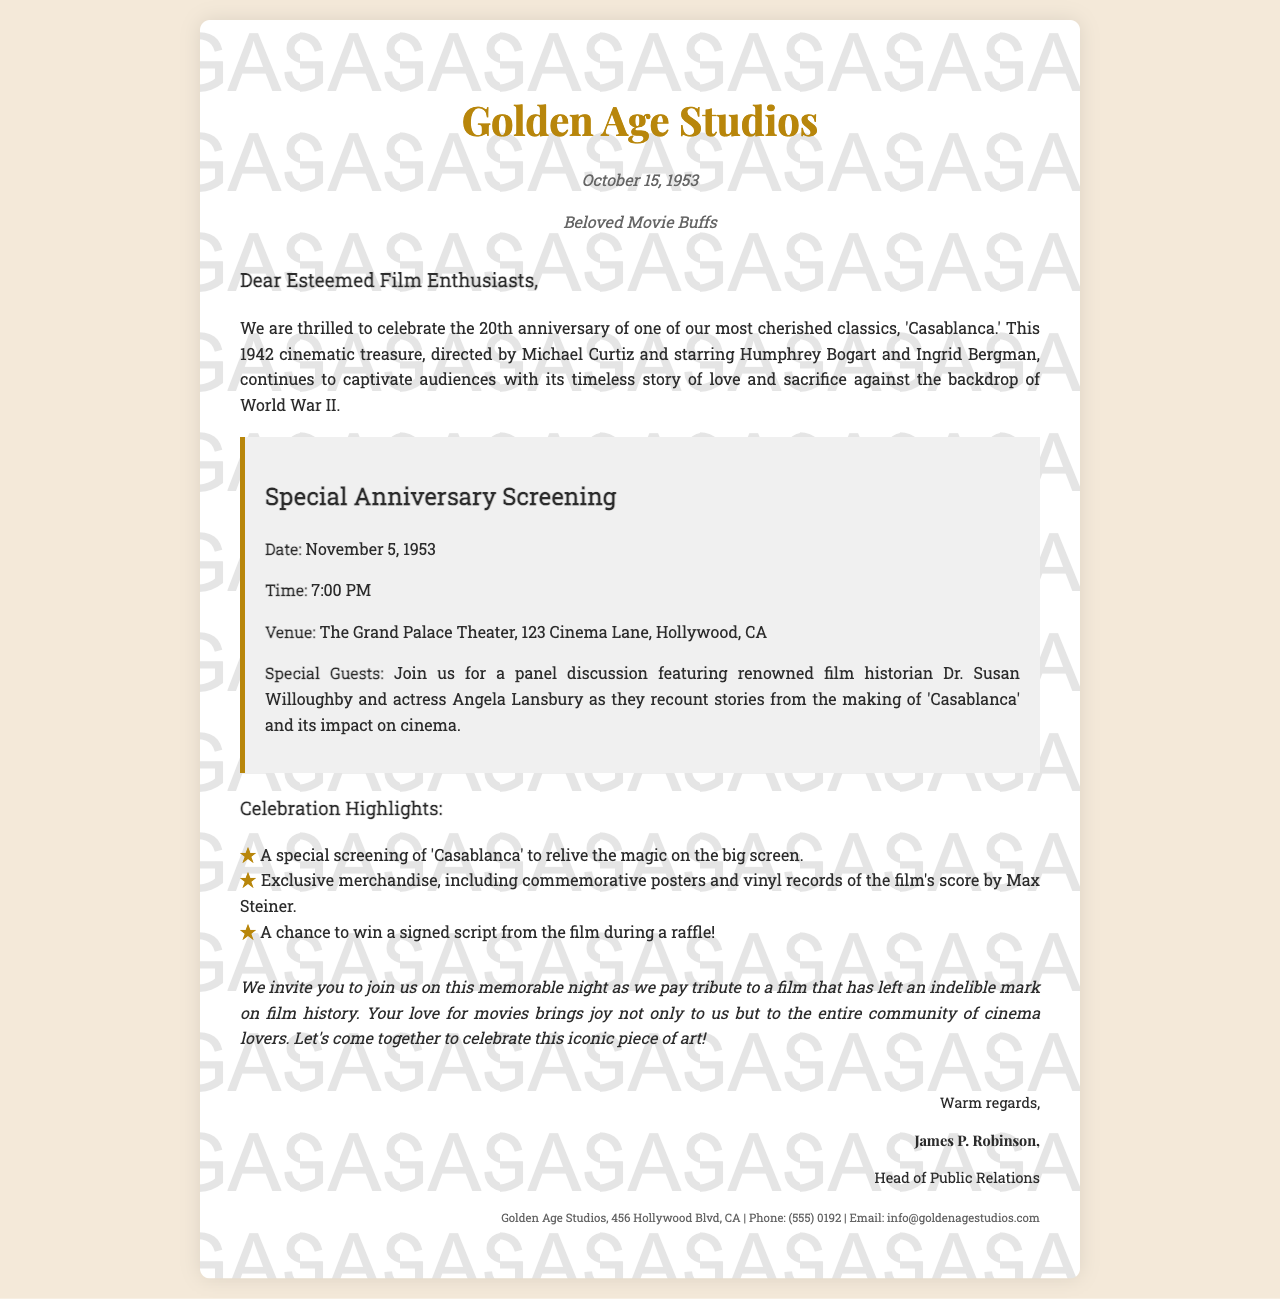What is the title of the classic film being celebrated? The title of the film being celebrated in the document is 'Casablanca.'
Answer: 'Casablanca' Who are the stars of 'Casablanca'? The stars of 'Casablanca' as mentioned in the document are Humphrey Bogart and Ingrid Bergman.
Answer: Humphrey Bogart and Ingrid Bergman What is the date of the special anniversary screening? The date of the special anniversary screening is November 5, 1953.
Answer: November 5, 1953 What time does the special screening begin? The special screening begins at 7:00 PM.
Answer: 7:00 PM Where is the special screening taking place? The venue for the special screening is The Grand Palace Theater, 123 Cinema Lane, Hollywood, CA.
Answer: The Grand Palace Theater, 123 Cinema Lane, Hollywood, CA Who is one of the special guests at the screening? One of the special guests at the screening is Dr. Susan Willoughby.
Answer: Dr. Susan Willoughby What major theme does the film 'Casablanca' portray? The major theme of 'Casablanca' is love and sacrifice against the backdrop of World War II.
Answer: love and sacrifice against the backdrop of World War II What type of merchandise will be available at the event? The event will feature exclusive merchandise, including commemorative posters and vinyl records of the film's score.
Answer: commemorative posters and vinyl records What is the purpose of the letter? The purpose of the letter is to invite film enthusiasts to celebrate the anniversary of 'Casablanca.'
Answer: to invite film enthusiasts to celebrate the anniversary of 'Casablanca' Who signed the letter? The letter is signed by James P. Robinson.
Answer: James P. Robinson 